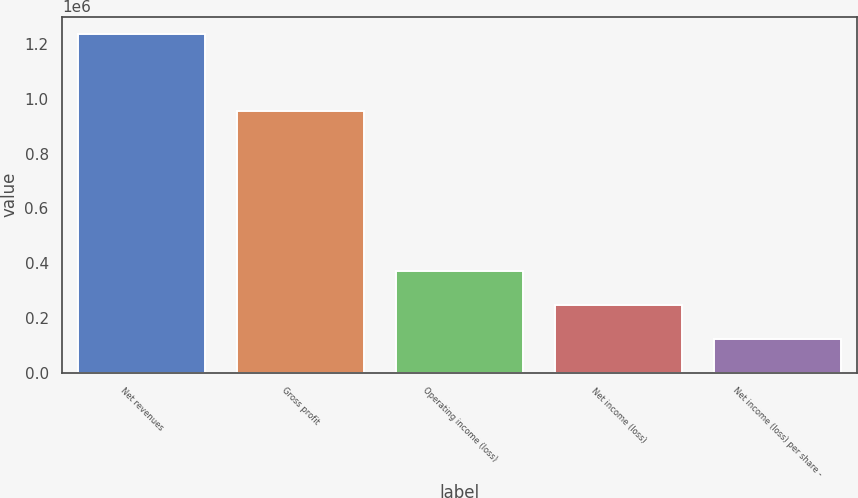Convert chart. <chart><loc_0><loc_0><loc_500><loc_500><bar_chart><fcel>Net revenues<fcel>Gross profit<fcel>Operating income (loss)<fcel>Net income (loss)<fcel>Net income (loss) per share -<nl><fcel>1.23856e+06<fcel>955406<fcel>371568<fcel>247712<fcel>123856<nl></chart> 